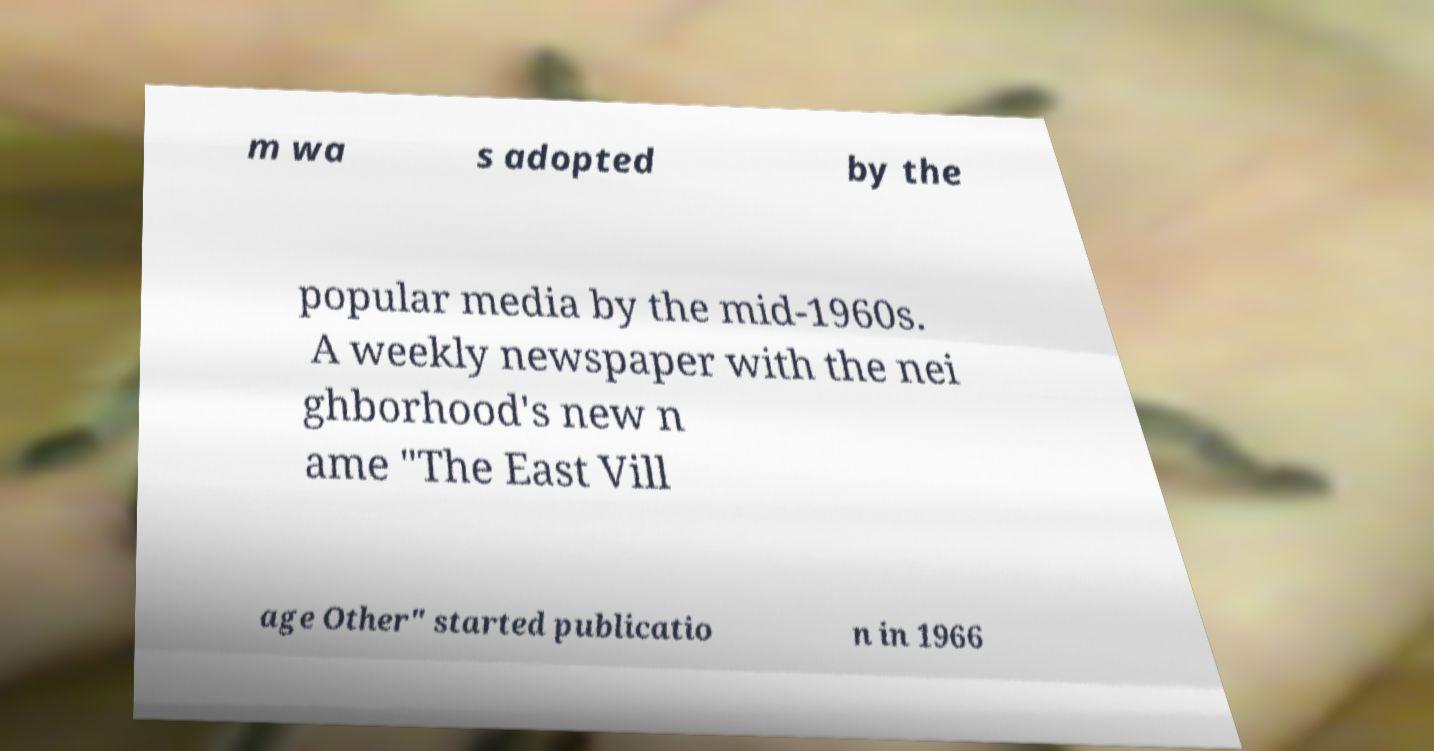Can you read and provide the text displayed in the image?This photo seems to have some interesting text. Can you extract and type it out for me? m wa s adopted by the popular media by the mid-1960s. A weekly newspaper with the nei ghborhood's new n ame "The East Vill age Other" started publicatio n in 1966 